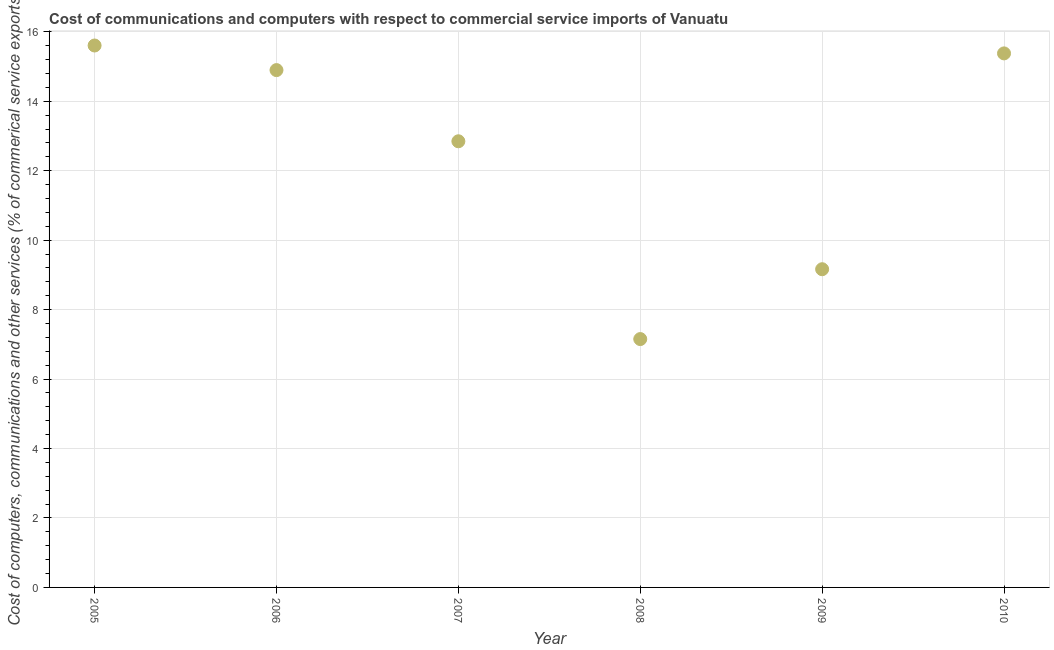What is the cost of communications in 2007?
Provide a succinct answer. 12.85. Across all years, what is the maximum cost of communications?
Give a very brief answer. 15.61. Across all years, what is the minimum  computer and other services?
Give a very brief answer. 7.15. In which year was the cost of communications maximum?
Ensure brevity in your answer.  2005. What is the sum of the cost of communications?
Give a very brief answer. 75.05. What is the difference between the cost of communications in 2007 and 2009?
Your response must be concise. 3.68. What is the average cost of communications per year?
Provide a short and direct response. 12.51. What is the median cost of communications?
Offer a very short reply. 13.87. In how many years, is the cost of communications greater than 13.2 %?
Your response must be concise. 3. Do a majority of the years between 2005 and 2008 (inclusive) have  computer and other services greater than 4.8 %?
Offer a terse response. Yes. What is the ratio of the cost of communications in 2005 to that in 2006?
Ensure brevity in your answer.  1.05. Is the cost of communications in 2005 less than that in 2009?
Your answer should be very brief. No. What is the difference between the highest and the second highest  computer and other services?
Your response must be concise. 0.23. Is the sum of the  computer and other services in 2009 and 2010 greater than the maximum  computer and other services across all years?
Your answer should be compact. Yes. What is the difference between the highest and the lowest  computer and other services?
Keep it short and to the point. 8.45. In how many years, is the  computer and other services greater than the average  computer and other services taken over all years?
Offer a terse response. 4. What is the difference between two consecutive major ticks on the Y-axis?
Your answer should be very brief. 2. What is the title of the graph?
Give a very brief answer. Cost of communications and computers with respect to commercial service imports of Vanuatu. What is the label or title of the X-axis?
Provide a succinct answer. Year. What is the label or title of the Y-axis?
Offer a very short reply. Cost of computers, communications and other services (% of commerical service exports). What is the Cost of computers, communications and other services (% of commerical service exports) in 2005?
Your answer should be compact. 15.61. What is the Cost of computers, communications and other services (% of commerical service exports) in 2006?
Keep it short and to the point. 14.9. What is the Cost of computers, communications and other services (% of commerical service exports) in 2007?
Your response must be concise. 12.85. What is the Cost of computers, communications and other services (% of commerical service exports) in 2008?
Your answer should be very brief. 7.15. What is the Cost of computers, communications and other services (% of commerical service exports) in 2009?
Offer a terse response. 9.16. What is the Cost of computers, communications and other services (% of commerical service exports) in 2010?
Offer a terse response. 15.38. What is the difference between the Cost of computers, communications and other services (% of commerical service exports) in 2005 and 2006?
Offer a very short reply. 0.71. What is the difference between the Cost of computers, communications and other services (% of commerical service exports) in 2005 and 2007?
Your answer should be very brief. 2.76. What is the difference between the Cost of computers, communications and other services (% of commerical service exports) in 2005 and 2008?
Provide a short and direct response. 8.45. What is the difference between the Cost of computers, communications and other services (% of commerical service exports) in 2005 and 2009?
Your response must be concise. 6.44. What is the difference between the Cost of computers, communications and other services (% of commerical service exports) in 2005 and 2010?
Your answer should be compact. 0.23. What is the difference between the Cost of computers, communications and other services (% of commerical service exports) in 2006 and 2007?
Offer a very short reply. 2.05. What is the difference between the Cost of computers, communications and other services (% of commerical service exports) in 2006 and 2008?
Offer a terse response. 7.75. What is the difference between the Cost of computers, communications and other services (% of commerical service exports) in 2006 and 2009?
Give a very brief answer. 5.73. What is the difference between the Cost of computers, communications and other services (% of commerical service exports) in 2006 and 2010?
Make the answer very short. -0.48. What is the difference between the Cost of computers, communications and other services (% of commerical service exports) in 2007 and 2008?
Offer a very short reply. 5.7. What is the difference between the Cost of computers, communications and other services (% of commerical service exports) in 2007 and 2009?
Provide a succinct answer. 3.68. What is the difference between the Cost of computers, communications and other services (% of commerical service exports) in 2007 and 2010?
Give a very brief answer. -2.53. What is the difference between the Cost of computers, communications and other services (% of commerical service exports) in 2008 and 2009?
Your response must be concise. -2.01. What is the difference between the Cost of computers, communications and other services (% of commerical service exports) in 2008 and 2010?
Provide a short and direct response. -8.23. What is the difference between the Cost of computers, communications and other services (% of commerical service exports) in 2009 and 2010?
Give a very brief answer. -6.22. What is the ratio of the Cost of computers, communications and other services (% of commerical service exports) in 2005 to that in 2006?
Ensure brevity in your answer.  1.05. What is the ratio of the Cost of computers, communications and other services (% of commerical service exports) in 2005 to that in 2007?
Give a very brief answer. 1.22. What is the ratio of the Cost of computers, communications and other services (% of commerical service exports) in 2005 to that in 2008?
Keep it short and to the point. 2.18. What is the ratio of the Cost of computers, communications and other services (% of commerical service exports) in 2005 to that in 2009?
Give a very brief answer. 1.7. What is the ratio of the Cost of computers, communications and other services (% of commerical service exports) in 2005 to that in 2010?
Provide a short and direct response. 1.01. What is the ratio of the Cost of computers, communications and other services (% of commerical service exports) in 2006 to that in 2007?
Give a very brief answer. 1.16. What is the ratio of the Cost of computers, communications and other services (% of commerical service exports) in 2006 to that in 2008?
Give a very brief answer. 2.08. What is the ratio of the Cost of computers, communications and other services (% of commerical service exports) in 2006 to that in 2009?
Offer a terse response. 1.63. What is the ratio of the Cost of computers, communications and other services (% of commerical service exports) in 2006 to that in 2010?
Make the answer very short. 0.97. What is the ratio of the Cost of computers, communications and other services (% of commerical service exports) in 2007 to that in 2008?
Ensure brevity in your answer.  1.8. What is the ratio of the Cost of computers, communications and other services (% of commerical service exports) in 2007 to that in 2009?
Offer a very short reply. 1.4. What is the ratio of the Cost of computers, communications and other services (% of commerical service exports) in 2007 to that in 2010?
Keep it short and to the point. 0.83. What is the ratio of the Cost of computers, communications and other services (% of commerical service exports) in 2008 to that in 2009?
Ensure brevity in your answer.  0.78. What is the ratio of the Cost of computers, communications and other services (% of commerical service exports) in 2008 to that in 2010?
Offer a terse response. 0.47. What is the ratio of the Cost of computers, communications and other services (% of commerical service exports) in 2009 to that in 2010?
Keep it short and to the point. 0.6. 